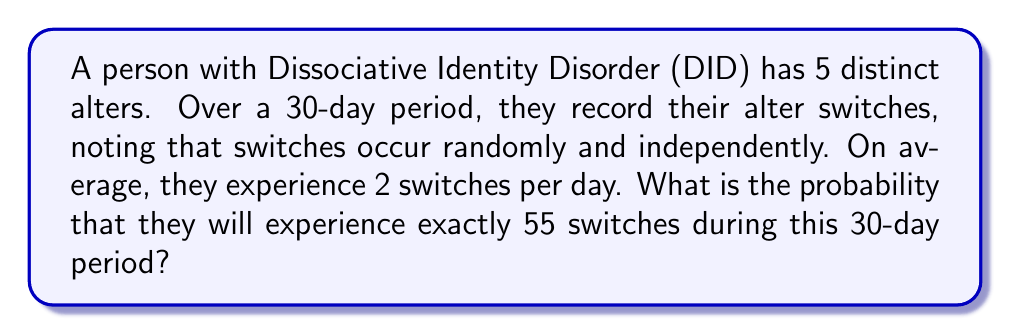What is the answer to this math problem? To solve this problem, we can use the Poisson distribution, which is suitable for modeling the number of events occurring in a fixed interval of time when these events happen with a known average rate and independently of each other.

The Poisson distribution is given by the formula:

$$P(X = k) = \frac{e^{-\lambda} \lambda^k}{k!}$$

Where:
$\lambda$ = average number of events in the interval
$k$ = number of events we're calculating the probability for
$e$ = Euler's number (approximately 2.71828)

For this problem:
$\lambda = 2 \text{ switches/day} \times 30 \text{ days} = 60 \text{ switches}$
$k = 55 \text{ switches}$

Plugging these values into the formula:

$$P(X = 55) = \frac{e^{-60} 60^{55}}{55!}$$

To calculate this:

1. $e^{-60} \approx 8.756 \times 10^{-27}$
2. $60^{55} \approx 6.169 \times 10^{97}$
3. $55! \approx 1.270 \times 10^{73}$

Putting it all together:

$$P(X = 55) = \frac{8.756 \times 10^{-27} \times 6.169 \times 10^{97}}{1.270 \times 10^{73}} \approx 0.0424$$

Therefore, the probability of experiencing exactly 55 switches during the 30-day period is approximately 0.0424 or 4.24%.
Answer: $0.0424$ or $4.24\%$ 